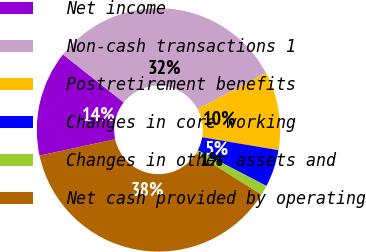<chart> <loc_0><loc_0><loc_500><loc_500><pie_chart><fcel>Net income<fcel>Non-cash transactions 1<fcel>Postretirement benefits<fcel>Changes in core working<fcel>Changes in other assets and<fcel>Net cash provided by operating<nl><fcel>14.04%<fcel>31.61%<fcel>10.41%<fcel>4.96%<fcel>1.32%<fcel>37.67%<nl></chart> 